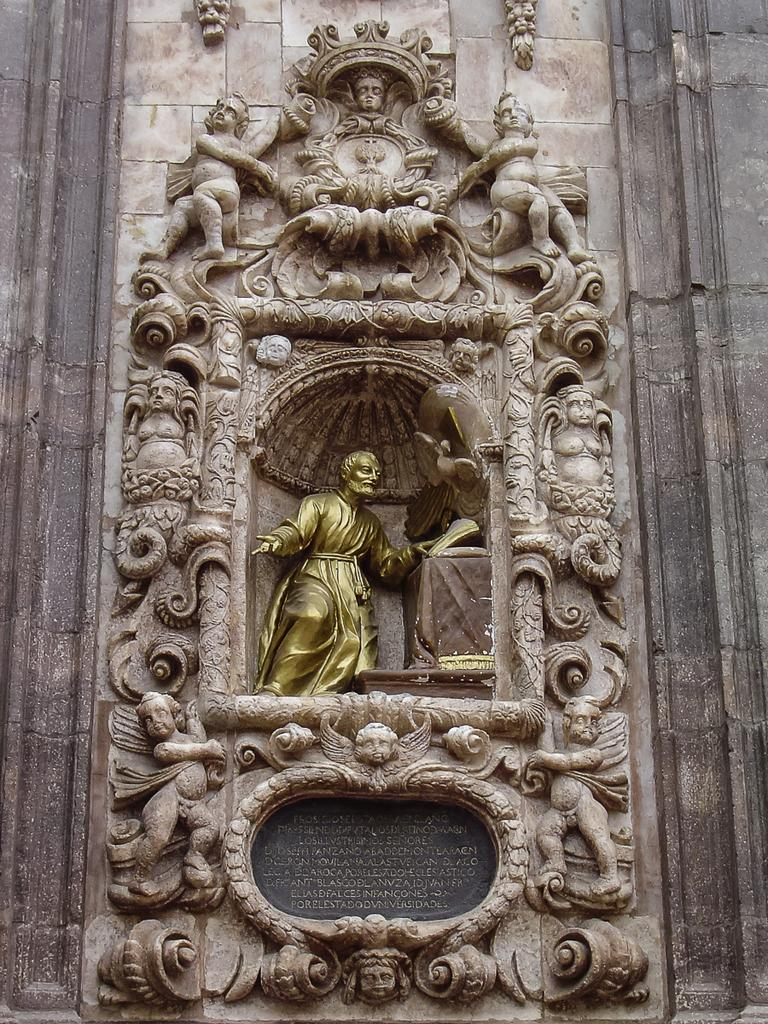What type of art is present in the image? There are sculptures in the image. Where are the sculptures located? The sculptures are on the wall. What type of mist can be seen surrounding the sculptures in the image? There is no mist present in the image; the sculptures are on the wall without any visible mist. 